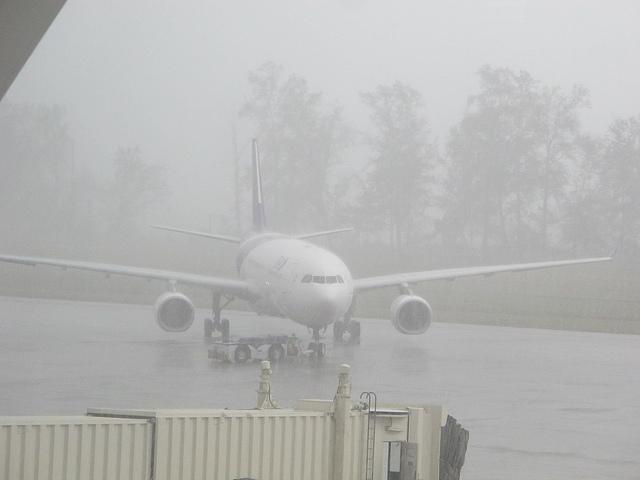How many people are eating?
Give a very brief answer. 0. 